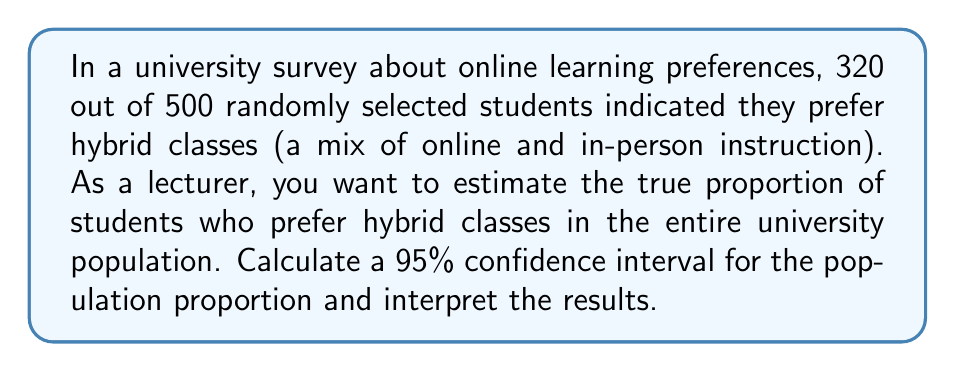What is the answer to this math problem? Let's approach this step-by-step:

1) First, we identify our variables:
   $n = 500$ (sample size)
   $x = 320$ (number of successes)
   $\hat{p} = \frac{x}{n} = \frac{320}{500} = 0.64$ (sample proportion)

2) For a 95% confidence interval, we use $z_{\alpha/2} = 1.96$

3) The formula for the confidence interval is:

   $$\hat{p} \pm z_{\alpha/2} \sqrt{\frac{\hat{p}(1-\hat{p})}{n}}$$

4) Let's calculate the margin of error:

   $$E = z_{\alpha/2} \sqrt{\frac{\hat{p}(1-\hat{p})}{n}}$$
   $$= 1.96 \sqrt{\frac{0.64(1-0.64)}{500}}$$
   $$= 1.96 \sqrt{\frac{0.2304}{500}}$$
   $$= 1.96 \sqrt{0.0004608}$$
   $$= 1.96 (0.02147)$$
   $$= 0.04208$$

5) Now we can calculate the confidence interval:

   Lower bound: $0.64 - 0.04208 = 0.59792$
   Upper bound: $0.64 + 0.04208 = 0.68208$

6) Interpretation: We are 95% confident that the true proportion of students in the university population who prefer hybrid classes is between 0.59792 and 0.68208, or approximately between 59.8% and 68.2%.
Answer: 95% CI: (0.59792, 0.68208) or (59.8%, 68.2%) 